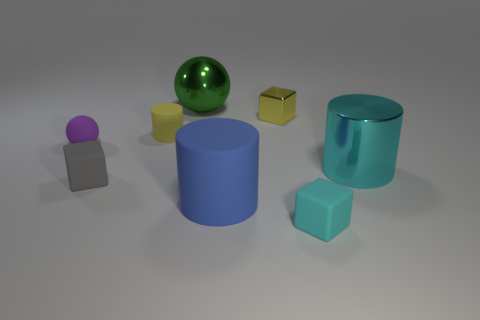How many blue things are rubber objects or small rubber objects?
Keep it short and to the point. 1. There is a matte block behind the rubber cube in front of the large blue cylinder; are there any blocks behind it?
Ensure brevity in your answer.  Yes. The matte object that is the same color as the shiny cylinder is what shape?
Provide a succinct answer. Cube. Are there any other things that are the same material as the large blue object?
Give a very brief answer. Yes. How many large things are purple matte spheres or green metallic blocks?
Keep it short and to the point. 0. Does the large object behind the purple rubber object have the same shape as the tiny cyan thing?
Give a very brief answer. No. Are there fewer red matte cubes than small matte cylinders?
Make the answer very short. Yes. Is there anything else that has the same color as the small cylinder?
Offer a terse response. Yes. What is the shape of the big metal thing on the left side of the small cyan block?
Provide a succinct answer. Sphere. Does the tiny metallic object have the same color as the small cube that is left of the green metallic ball?
Offer a very short reply. No. 